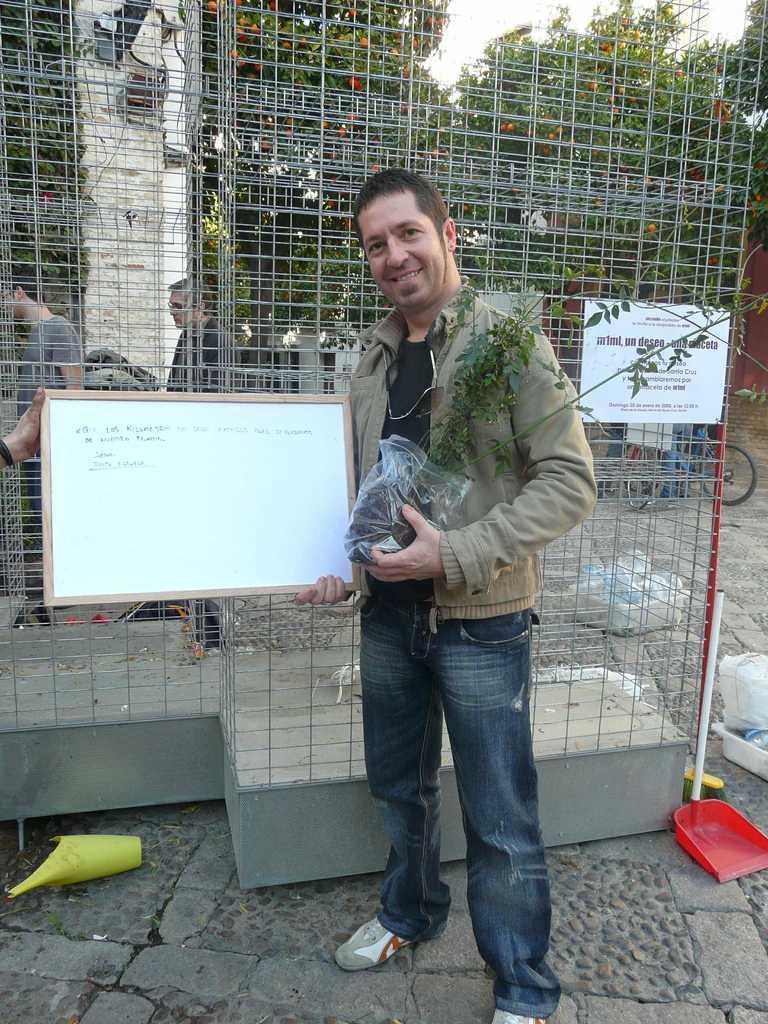Please provide a concise description of this image. This is an outside view. Here I can see a man standing, holding a plant and a board in the hands, smiling and giving pose for the picture. On the left side, I can see another person's hand holding this board. At the bottom there are few objects placed on the floor. At the back of this man there is a net. In the background, I can see few people are standing facing towards the left side and there is a pillar. In the background there are many trees. On the right side there are two bicycles. 